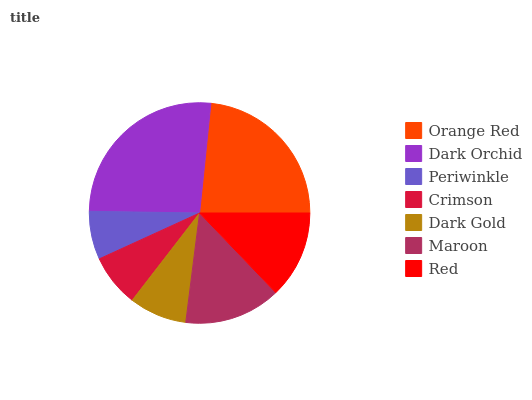Is Periwinkle the minimum?
Answer yes or no. Yes. Is Dark Orchid the maximum?
Answer yes or no. Yes. Is Dark Orchid the minimum?
Answer yes or no. No. Is Periwinkle the maximum?
Answer yes or no. No. Is Dark Orchid greater than Periwinkle?
Answer yes or no. Yes. Is Periwinkle less than Dark Orchid?
Answer yes or no. Yes. Is Periwinkle greater than Dark Orchid?
Answer yes or no. No. Is Dark Orchid less than Periwinkle?
Answer yes or no. No. Is Red the high median?
Answer yes or no. Yes. Is Red the low median?
Answer yes or no. Yes. Is Maroon the high median?
Answer yes or no. No. Is Dark Gold the low median?
Answer yes or no. No. 